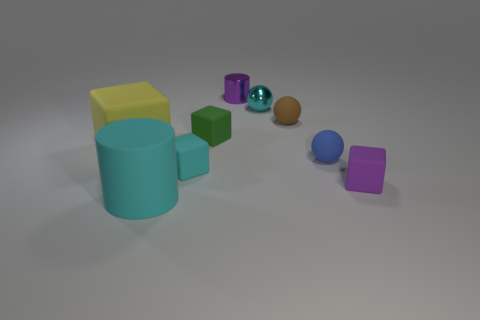Add 1 yellow metallic blocks. How many objects exist? 10 Subtract all cylinders. How many objects are left? 7 Subtract 1 yellow cubes. How many objects are left? 8 Subtract all blue blocks. Subtract all small spheres. How many objects are left? 6 Add 8 purple metallic cylinders. How many purple metallic cylinders are left? 9 Add 9 cyan shiny cubes. How many cyan shiny cubes exist? 9 